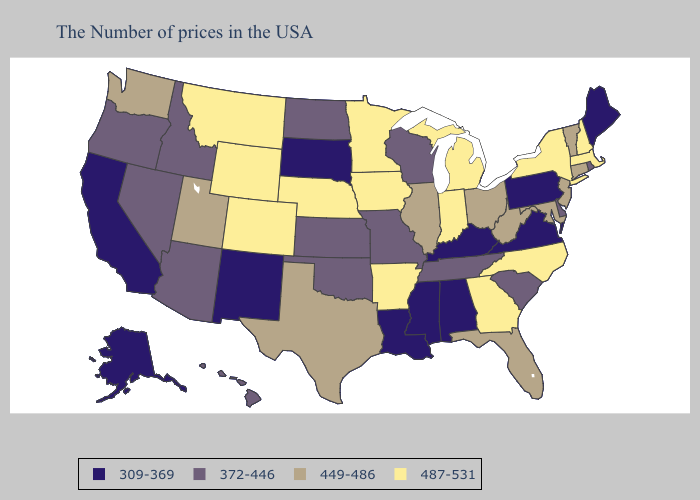Does the first symbol in the legend represent the smallest category?
Quick response, please. Yes. Name the states that have a value in the range 487-531?
Answer briefly. Massachusetts, New Hampshire, New York, North Carolina, Georgia, Michigan, Indiana, Arkansas, Minnesota, Iowa, Nebraska, Wyoming, Colorado, Montana. Name the states that have a value in the range 309-369?
Short answer required. Maine, Pennsylvania, Virginia, Kentucky, Alabama, Mississippi, Louisiana, South Dakota, New Mexico, California, Alaska. What is the lowest value in the Northeast?
Write a very short answer. 309-369. What is the value of South Dakota?
Be succinct. 309-369. What is the highest value in states that border Pennsylvania?
Short answer required. 487-531. What is the value of Tennessee?
Answer briefly. 372-446. Among the states that border Maine , which have the highest value?
Short answer required. New Hampshire. What is the value of Minnesota?
Concise answer only. 487-531. What is the value of Rhode Island?
Concise answer only. 372-446. Name the states that have a value in the range 487-531?
Keep it brief. Massachusetts, New Hampshire, New York, North Carolina, Georgia, Michigan, Indiana, Arkansas, Minnesota, Iowa, Nebraska, Wyoming, Colorado, Montana. Among the states that border South Dakota , does North Dakota have the highest value?
Short answer required. No. Among the states that border Oregon , which have the lowest value?
Be succinct. California. Name the states that have a value in the range 449-486?
Write a very short answer. Vermont, Connecticut, New Jersey, Maryland, West Virginia, Ohio, Florida, Illinois, Texas, Utah, Washington. Name the states that have a value in the range 487-531?
Be succinct. Massachusetts, New Hampshire, New York, North Carolina, Georgia, Michigan, Indiana, Arkansas, Minnesota, Iowa, Nebraska, Wyoming, Colorado, Montana. 